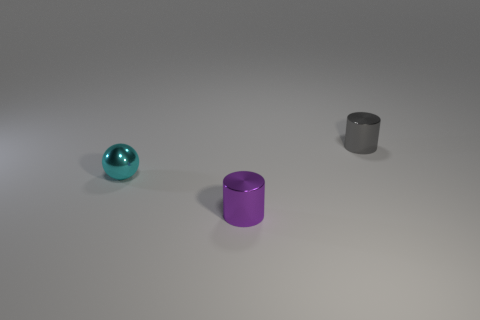Imagine a scenario where these objects are part of a larger context. What could that context be? Envision these objects as part of an artist's still-life composition, carefully arranged to play on contrasts in colors and shapes. Their simplicity evokes a modernist aesthetic, where the focus is on form and the interplay of light. Alternatively, they might serve as physical prototypes for a designer conceptualizing new homeware products, experimenting with different materials and geometric forms to create a harmonious balance for decorative or functional use. 